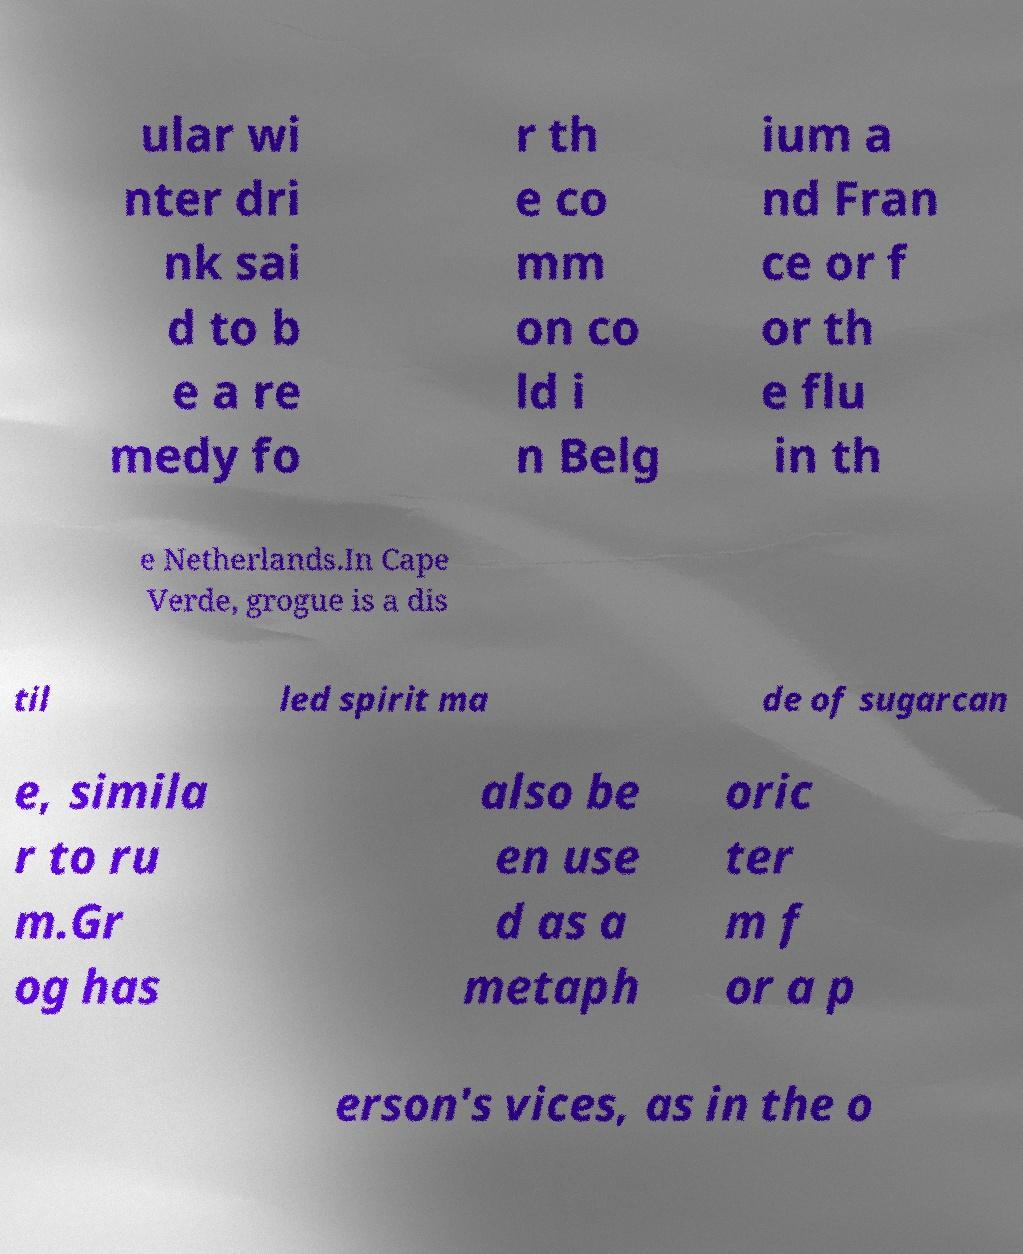Could you assist in decoding the text presented in this image and type it out clearly? ular wi nter dri nk sai d to b e a re medy fo r th e co mm on co ld i n Belg ium a nd Fran ce or f or th e flu in th e Netherlands.In Cape Verde, grogue is a dis til led spirit ma de of sugarcan e, simila r to ru m.Gr og has also be en use d as a metaph oric ter m f or a p erson's vices, as in the o 